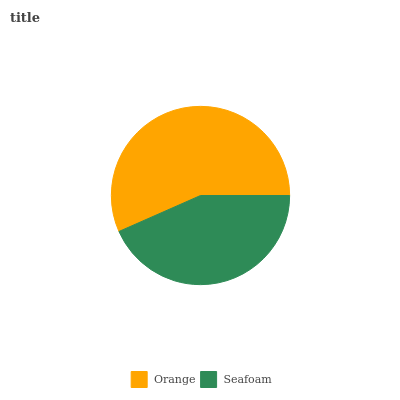Is Seafoam the minimum?
Answer yes or no. Yes. Is Orange the maximum?
Answer yes or no. Yes. Is Seafoam the maximum?
Answer yes or no. No. Is Orange greater than Seafoam?
Answer yes or no. Yes. Is Seafoam less than Orange?
Answer yes or no. Yes. Is Seafoam greater than Orange?
Answer yes or no. No. Is Orange less than Seafoam?
Answer yes or no. No. Is Orange the high median?
Answer yes or no. Yes. Is Seafoam the low median?
Answer yes or no. Yes. Is Seafoam the high median?
Answer yes or no. No. Is Orange the low median?
Answer yes or no. No. 